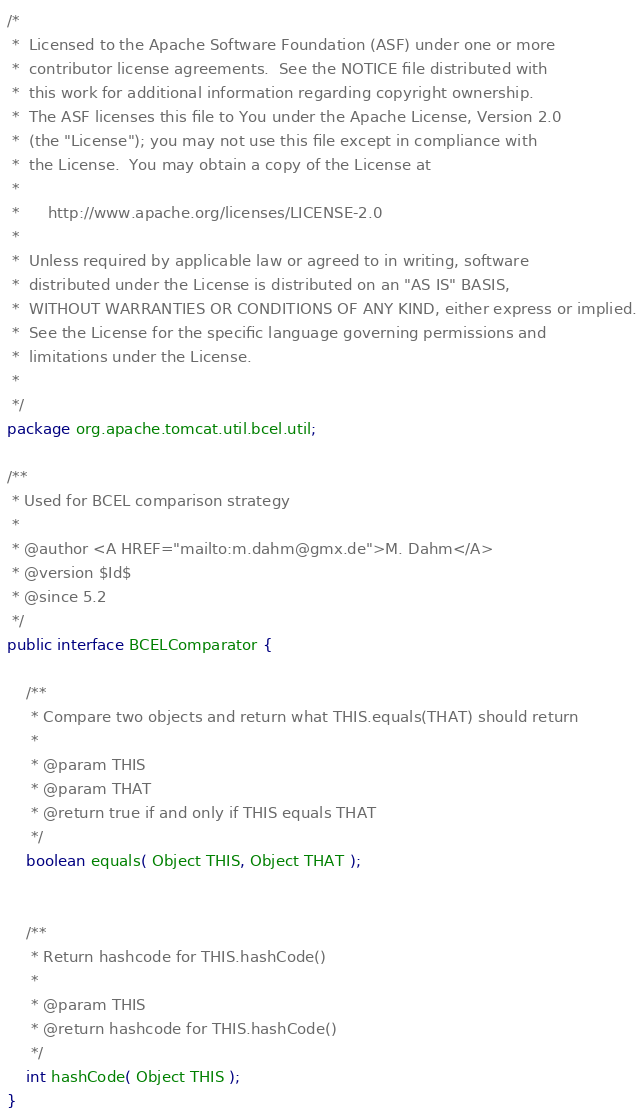Convert code to text. <code><loc_0><loc_0><loc_500><loc_500><_Java_>/*
 *  Licensed to the Apache Software Foundation (ASF) under one or more
 *  contributor license agreements.  See the NOTICE file distributed with
 *  this work for additional information regarding copyright ownership.
 *  The ASF licenses this file to You under the Apache License, Version 2.0
 *  (the "License"); you may not use this file except in compliance with
 *  the License.  You may obtain a copy of the License at
 *
 *      http://www.apache.org/licenses/LICENSE-2.0
 *
 *  Unless required by applicable law or agreed to in writing, software
 *  distributed under the License is distributed on an "AS IS" BASIS,
 *  WITHOUT WARRANTIES OR CONDITIONS OF ANY KIND, either express or implied.
 *  See the License for the specific language governing permissions and
 *  limitations under the License.
 *
 */
package org.apache.tomcat.util.bcel.util;

/**
 * Used for BCEL comparison strategy
 *
 * @author <A HREF="mailto:m.dahm@gmx.de">M. Dahm</A>
 * @version $Id$
 * @since 5.2
 */
public interface BCELComparator {

    /**
     * Compare two objects and return what THIS.equals(THAT) should return
     *
     * @param THIS
     * @param THAT
     * @return true if and only if THIS equals THAT
     */
    boolean equals( Object THIS, Object THAT );


    /**
     * Return hashcode for THIS.hashCode()
     *
     * @param THIS
     * @return hashcode for THIS.hashCode()
     */
    int hashCode( Object THIS );
}
</code> 